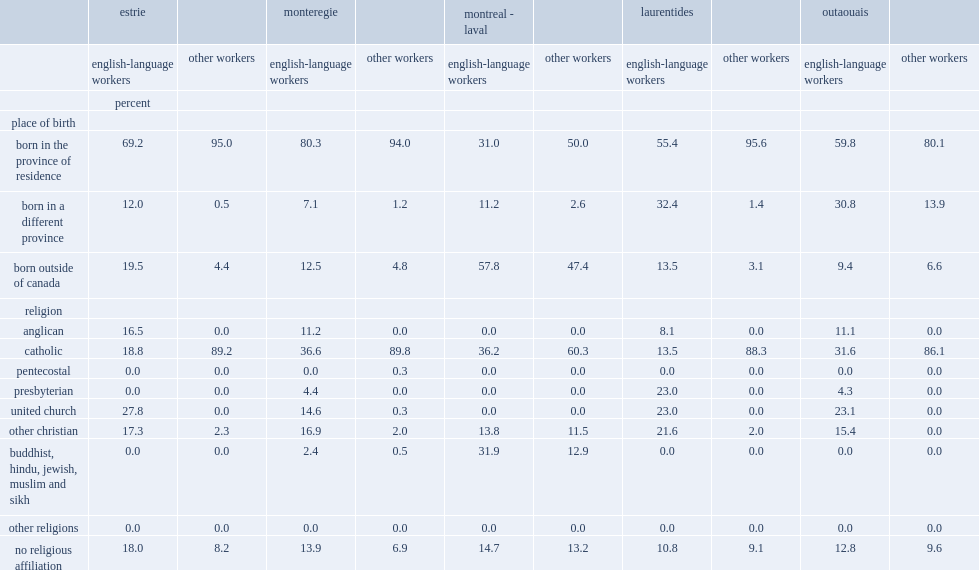Which language group of workers was less likley to have been born in their province of residence? english-language workers or other workers? English-language workers. Which language group of workers was more likley to have been born in another canadian province or outside canada among all the agricultural regions of quebec? english-language workers or other workers? English-language workers. Which language group of workers in quebec was much less likely to be catholic in 2011? english-language workers or other workers? English-language workers. Which language group of workers was more likely to declare having no religious affilliation in all five agricultural regions of quebec? english-language workers or other workers? English-language workers. 